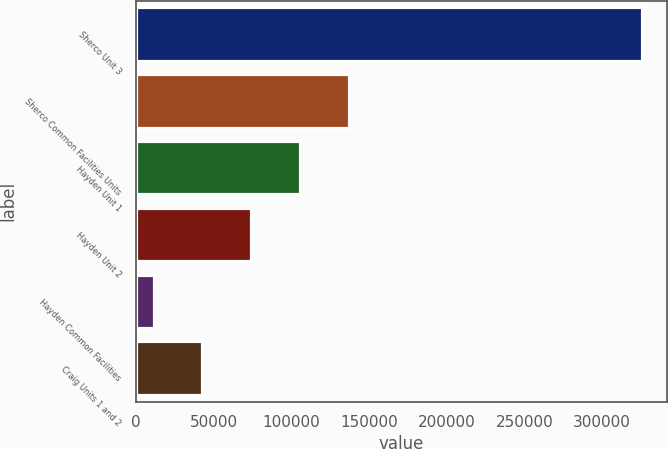Convert chart to OTSL. <chart><loc_0><loc_0><loc_500><loc_500><bar_chart><fcel>Sherco Unit 3<fcel>Sherco Common Facilities Units<fcel>Hayden Unit 1<fcel>Hayden Unit 2<fcel>Hayden Common Facilities<fcel>Craig Units 1 and 2<nl><fcel>325472<fcel>137076<fcel>105677<fcel>74277.6<fcel>11479<fcel>42878.3<nl></chart> 